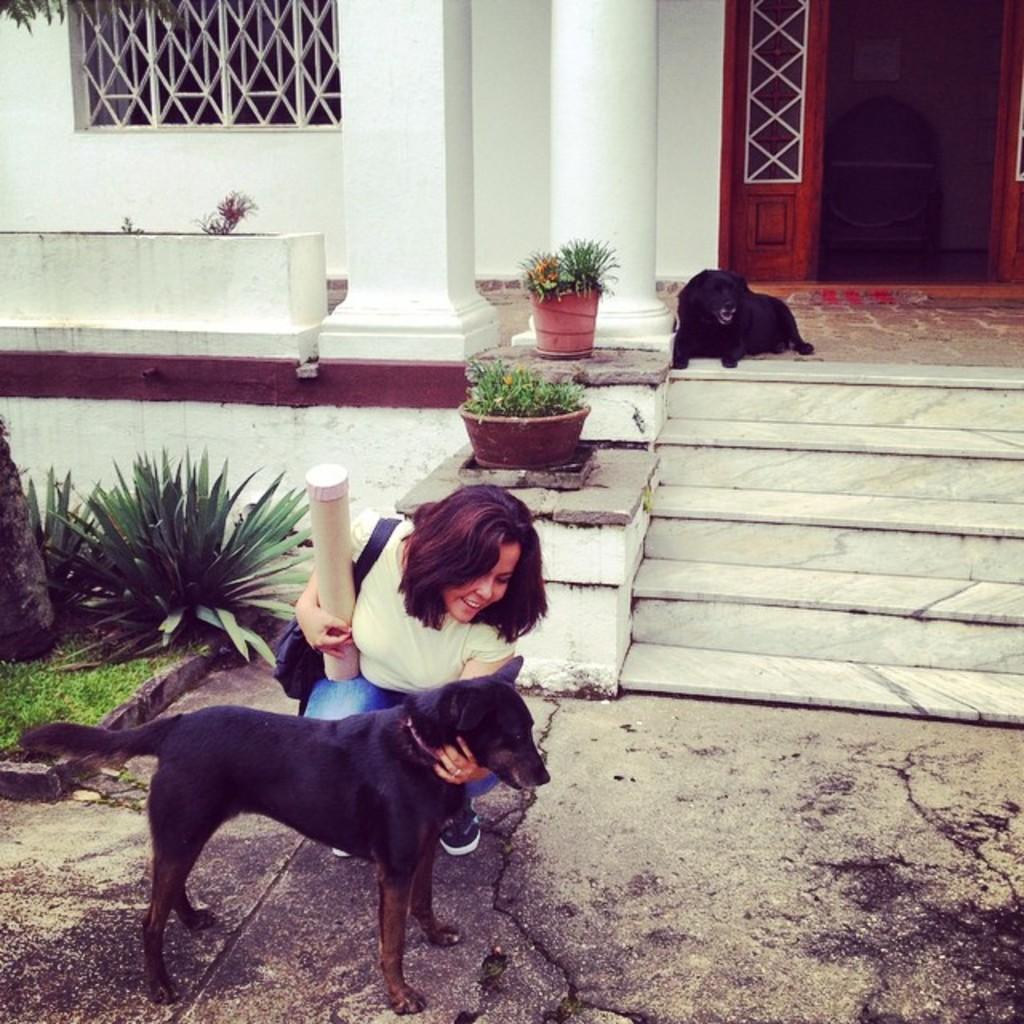Could you give a brief overview of what you see in this image? This is the woman sitting in the squat position and holding an object. I can see a dog standing. These are the stairs. I can see the pillars. This looks like the bushes and the grass. These are the flower pots with the flowers. Here is the another dog sitting. This looks like a window. 